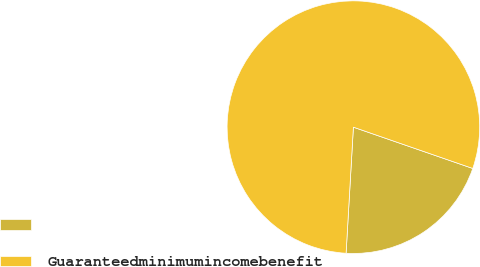Convert chart to OTSL. <chart><loc_0><loc_0><loc_500><loc_500><pie_chart><ecel><fcel>Guaranteedminimumincomebenefit<nl><fcel>20.62%<fcel>79.38%<nl></chart> 